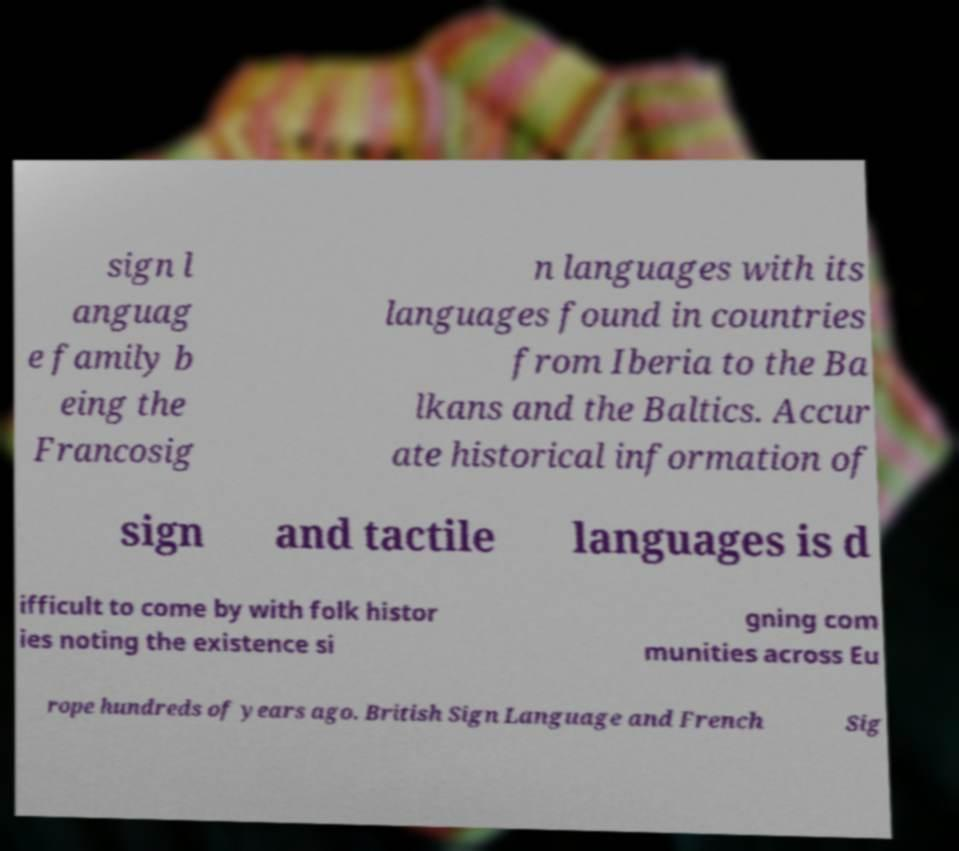Could you extract and type out the text from this image? sign l anguag e family b eing the Francosig n languages with its languages found in countries from Iberia to the Ba lkans and the Baltics. Accur ate historical information of sign and tactile languages is d ifficult to come by with folk histor ies noting the existence si gning com munities across Eu rope hundreds of years ago. British Sign Language and French Sig 